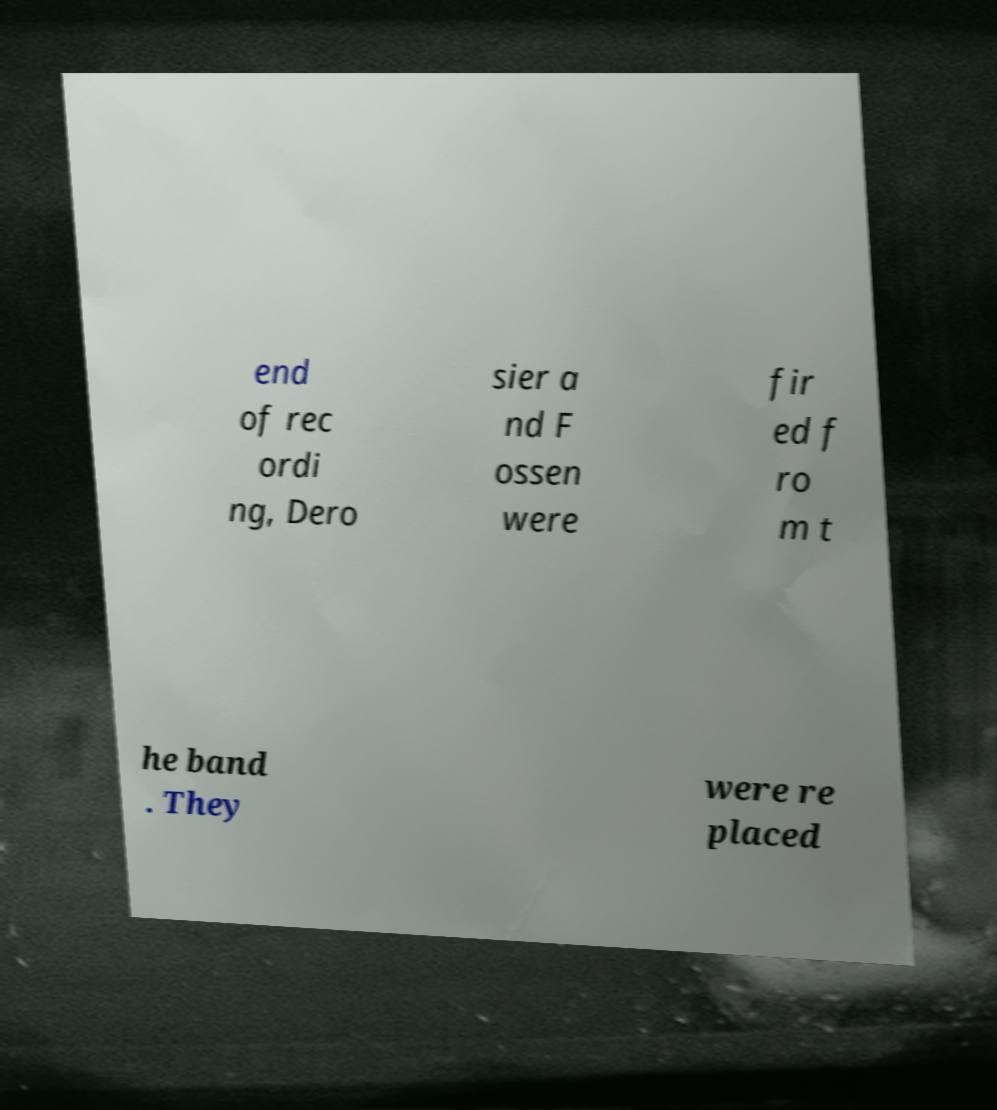There's text embedded in this image that I need extracted. Can you transcribe it verbatim? end of rec ordi ng, Dero sier a nd F ossen were fir ed f ro m t he band . They were re placed 